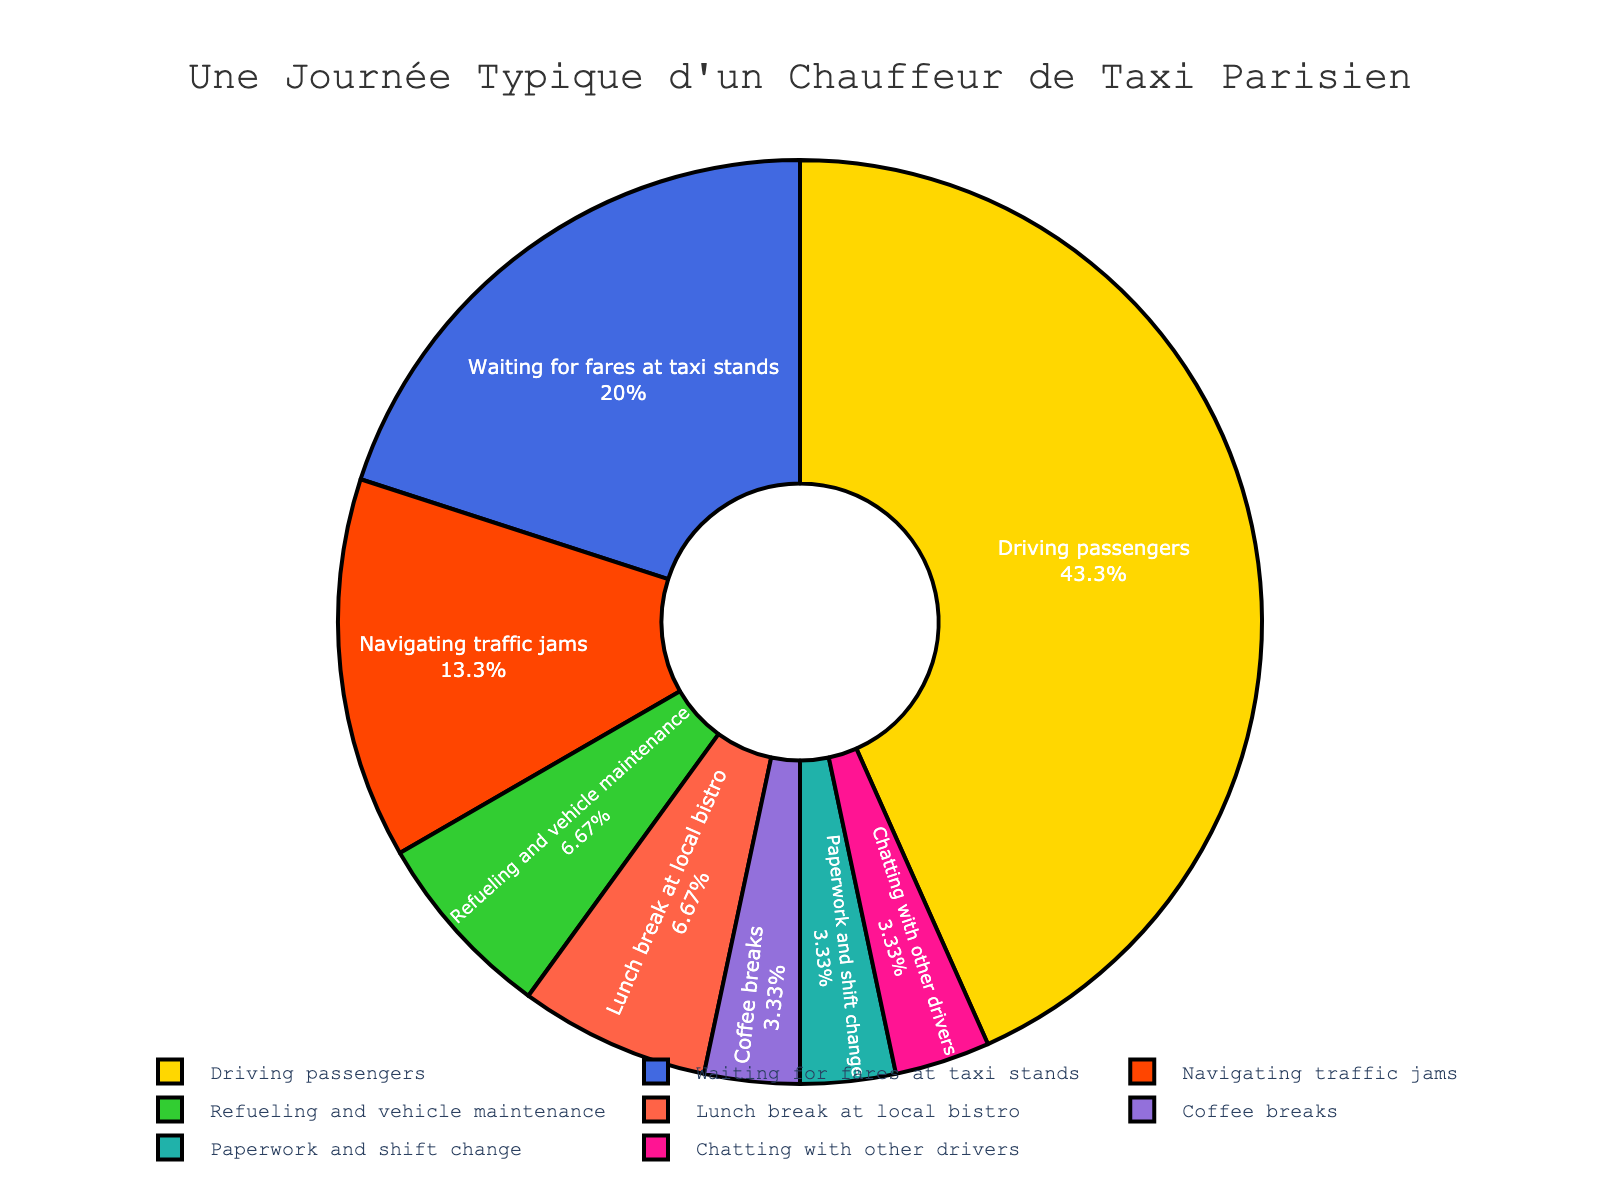What percentage of the cab driver's day is spent driving passengers? The slice labeled "Driving passengers" shows the percentage of the total hours allocated in the pie chart.
Answer: 54.2% Which activity takes the second most time after driving passengers? To determine this, look for the activity with the second largest slice in the pie chart.
Answer: Navigating traffic jams How much more time is spent driving passengers compared to waiting for fares at taxi stands? Subtract the hours for "Waiting for fares at taxi stands" from the hours for "Driving passengers": 6.5 - 3 = 3.5 hours.
Answer: 3.5 hours What activities combined take up the same amount of time as driving passengers? Sum the hours of the smaller activities to see which combination equals 6.5 hours: 3 (Waiting for fares) + 2 (Navigating traffic jams) + 1 (Refueling and maintenance) + 0.5 (Paperwork) = 6.5 hours.
Answer: Waiting for fares, navigating traffic jams, refueling and maintenance, paperwork What fraction of the day is spent on breaks (lunch and coffee)? Add the hours for "Lunch break at local bistro" and "Coffee breaks": 1 + 0.5 = 1.5 hours. Then divide by the total hours (15): 1.5 / 15 = 0.1.
Answer: 0.1 Which activity is least time-consuming? Identify the smallest slice in the pie chart; this corresponds to "Chatting with other drivers" and "Paperwork and shift change."
Answer: Chatting with other drivers and paperwork Does the cab driver spend more time taking coffee breaks than refueling and vehicle maintenance? Compare the hours: coffee breaks (0.5 hours) vs. refueling and vehicle maintenance (1 hour).
Answer: No What visual attribute confirms that "Driving passengers" occupies the most time? The "Driving passengers" slice is the largest in the pie chart and takes up more visual space than the others.
Answer: Largest slice How much total time is spent on activities other than driving passengers and waiting for fares? Subtract the hours of "Driving passengers" and "Waiting for fares" from the total hours: 15 - (6.5 + 3) = 5.5 hours.
Answer: 5.5 hours 